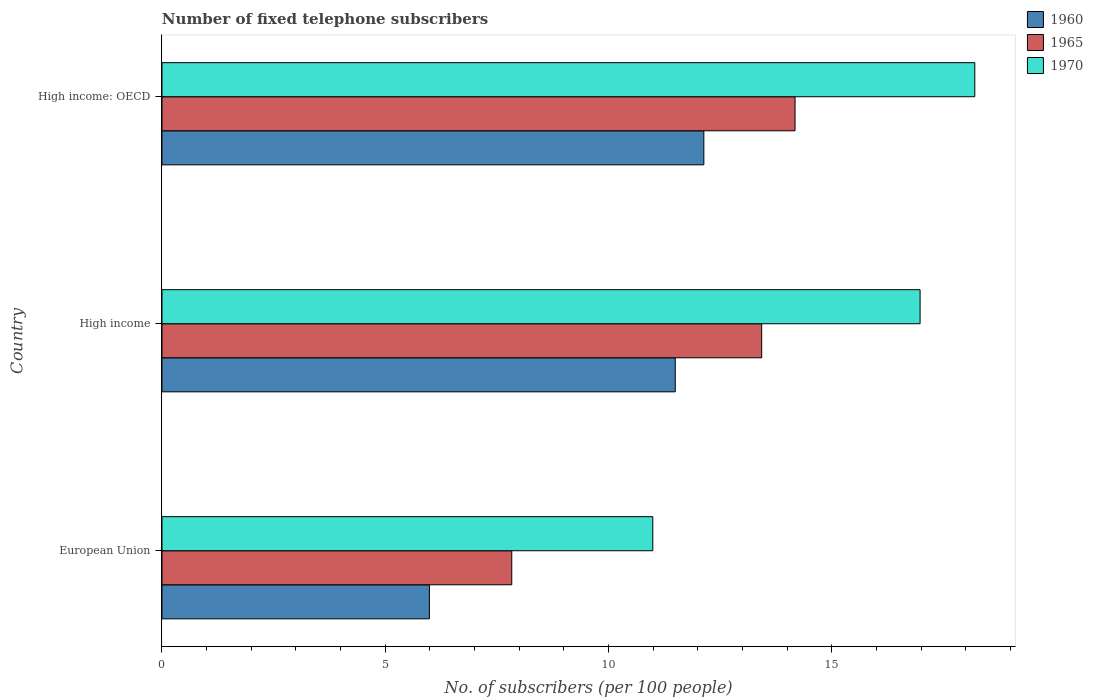How many different coloured bars are there?
Make the answer very short. 3. How many groups of bars are there?
Offer a terse response. 3. Are the number of bars per tick equal to the number of legend labels?
Provide a succinct answer. Yes. Are the number of bars on each tick of the Y-axis equal?
Your answer should be very brief. Yes. How many bars are there on the 3rd tick from the top?
Your response must be concise. 3. In how many cases, is the number of bars for a given country not equal to the number of legend labels?
Your response must be concise. 0. What is the number of fixed telephone subscribers in 1970 in High income?
Offer a terse response. 16.97. Across all countries, what is the maximum number of fixed telephone subscribers in 1960?
Your answer should be compact. 12.13. Across all countries, what is the minimum number of fixed telephone subscribers in 1970?
Offer a very short reply. 10.99. In which country was the number of fixed telephone subscribers in 1970 maximum?
Your answer should be very brief. High income: OECD. What is the total number of fixed telephone subscribers in 1965 in the graph?
Ensure brevity in your answer.  35.43. What is the difference between the number of fixed telephone subscribers in 1965 in European Union and that in High income?
Your response must be concise. -5.6. What is the difference between the number of fixed telephone subscribers in 1960 in High income: OECD and the number of fixed telephone subscribers in 1970 in European Union?
Ensure brevity in your answer.  1.14. What is the average number of fixed telephone subscribers in 1970 per country?
Make the answer very short. 15.39. What is the difference between the number of fixed telephone subscribers in 1965 and number of fixed telephone subscribers in 1970 in European Union?
Your answer should be compact. -3.16. What is the ratio of the number of fixed telephone subscribers in 1960 in European Union to that in High income: OECD?
Ensure brevity in your answer.  0.49. Is the number of fixed telephone subscribers in 1970 in European Union less than that in High income: OECD?
Offer a very short reply. Yes. What is the difference between the highest and the second highest number of fixed telephone subscribers in 1960?
Offer a terse response. 0.64. What is the difference between the highest and the lowest number of fixed telephone subscribers in 1965?
Make the answer very short. 6.34. What does the 2nd bar from the top in High income: OECD represents?
Your answer should be compact. 1965. Is it the case that in every country, the sum of the number of fixed telephone subscribers in 1960 and number of fixed telephone subscribers in 1970 is greater than the number of fixed telephone subscribers in 1965?
Give a very brief answer. Yes. How many bars are there?
Your answer should be very brief. 9. Are all the bars in the graph horizontal?
Your response must be concise. Yes. Are the values on the major ticks of X-axis written in scientific E-notation?
Offer a very short reply. No. Does the graph contain any zero values?
Provide a succinct answer. No. Where does the legend appear in the graph?
Your response must be concise. Top right. What is the title of the graph?
Ensure brevity in your answer.  Number of fixed telephone subscribers. What is the label or title of the X-axis?
Keep it short and to the point. No. of subscribers (per 100 people). What is the No. of subscribers (per 100 people) in 1960 in European Union?
Your answer should be very brief. 5.99. What is the No. of subscribers (per 100 people) of 1965 in European Union?
Offer a terse response. 7.83. What is the No. of subscribers (per 100 people) in 1970 in European Union?
Your answer should be compact. 10.99. What is the No. of subscribers (per 100 people) of 1960 in High income?
Your response must be concise. 11.49. What is the No. of subscribers (per 100 people) in 1965 in High income?
Make the answer very short. 13.43. What is the No. of subscribers (per 100 people) of 1970 in High income?
Your answer should be compact. 16.97. What is the No. of subscribers (per 100 people) of 1960 in High income: OECD?
Provide a succinct answer. 12.13. What is the No. of subscribers (per 100 people) of 1965 in High income: OECD?
Your answer should be very brief. 14.17. What is the No. of subscribers (per 100 people) in 1970 in High income: OECD?
Your answer should be very brief. 18.2. Across all countries, what is the maximum No. of subscribers (per 100 people) of 1960?
Provide a short and direct response. 12.13. Across all countries, what is the maximum No. of subscribers (per 100 people) of 1965?
Offer a very short reply. 14.17. Across all countries, what is the maximum No. of subscribers (per 100 people) in 1970?
Give a very brief answer. 18.2. Across all countries, what is the minimum No. of subscribers (per 100 people) of 1960?
Your answer should be compact. 5.99. Across all countries, what is the minimum No. of subscribers (per 100 people) of 1965?
Provide a short and direct response. 7.83. Across all countries, what is the minimum No. of subscribers (per 100 people) of 1970?
Offer a terse response. 10.99. What is the total No. of subscribers (per 100 people) in 1960 in the graph?
Make the answer very short. 29.61. What is the total No. of subscribers (per 100 people) in 1965 in the graph?
Keep it short and to the point. 35.43. What is the total No. of subscribers (per 100 people) in 1970 in the graph?
Offer a terse response. 46.16. What is the difference between the No. of subscribers (per 100 people) in 1960 in European Union and that in High income?
Provide a short and direct response. -5.5. What is the difference between the No. of subscribers (per 100 people) in 1965 in European Union and that in High income?
Your answer should be compact. -5.6. What is the difference between the No. of subscribers (per 100 people) of 1970 in European Union and that in High income?
Your response must be concise. -5.98. What is the difference between the No. of subscribers (per 100 people) in 1960 in European Union and that in High income: OECD?
Make the answer very short. -6.14. What is the difference between the No. of subscribers (per 100 people) in 1965 in European Union and that in High income: OECD?
Make the answer very short. -6.34. What is the difference between the No. of subscribers (per 100 people) in 1970 in European Union and that in High income: OECD?
Provide a succinct answer. -7.21. What is the difference between the No. of subscribers (per 100 people) in 1960 in High income and that in High income: OECD?
Make the answer very short. -0.64. What is the difference between the No. of subscribers (per 100 people) in 1965 in High income and that in High income: OECD?
Your response must be concise. -0.75. What is the difference between the No. of subscribers (per 100 people) of 1970 in High income and that in High income: OECD?
Your answer should be compact. -1.22. What is the difference between the No. of subscribers (per 100 people) in 1960 in European Union and the No. of subscribers (per 100 people) in 1965 in High income?
Your answer should be compact. -7.44. What is the difference between the No. of subscribers (per 100 people) of 1960 in European Union and the No. of subscribers (per 100 people) of 1970 in High income?
Keep it short and to the point. -10.99. What is the difference between the No. of subscribers (per 100 people) of 1965 in European Union and the No. of subscribers (per 100 people) of 1970 in High income?
Give a very brief answer. -9.14. What is the difference between the No. of subscribers (per 100 people) of 1960 in European Union and the No. of subscribers (per 100 people) of 1965 in High income: OECD?
Make the answer very short. -8.19. What is the difference between the No. of subscribers (per 100 people) of 1960 in European Union and the No. of subscribers (per 100 people) of 1970 in High income: OECD?
Ensure brevity in your answer.  -12.21. What is the difference between the No. of subscribers (per 100 people) in 1965 in European Union and the No. of subscribers (per 100 people) in 1970 in High income: OECD?
Your answer should be compact. -10.37. What is the difference between the No. of subscribers (per 100 people) of 1960 in High income and the No. of subscribers (per 100 people) of 1965 in High income: OECD?
Offer a terse response. -2.68. What is the difference between the No. of subscribers (per 100 people) of 1960 in High income and the No. of subscribers (per 100 people) of 1970 in High income: OECD?
Provide a short and direct response. -6.71. What is the difference between the No. of subscribers (per 100 people) of 1965 in High income and the No. of subscribers (per 100 people) of 1970 in High income: OECD?
Offer a terse response. -4.77. What is the average No. of subscribers (per 100 people) in 1960 per country?
Your response must be concise. 9.87. What is the average No. of subscribers (per 100 people) in 1965 per country?
Your response must be concise. 11.81. What is the average No. of subscribers (per 100 people) of 1970 per country?
Keep it short and to the point. 15.39. What is the difference between the No. of subscribers (per 100 people) in 1960 and No. of subscribers (per 100 people) in 1965 in European Union?
Offer a very short reply. -1.84. What is the difference between the No. of subscribers (per 100 people) in 1960 and No. of subscribers (per 100 people) in 1970 in European Union?
Your answer should be compact. -5. What is the difference between the No. of subscribers (per 100 people) in 1965 and No. of subscribers (per 100 people) in 1970 in European Union?
Your answer should be very brief. -3.16. What is the difference between the No. of subscribers (per 100 people) in 1960 and No. of subscribers (per 100 people) in 1965 in High income?
Provide a short and direct response. -1.93. What is the difference between the No. of subscribers (per 100 people) in 1960 and No. of subscribers (per 100 people) in 1970 in High income?
Your answer should be compact. -5.48. What is the difference between the No. of subscribers (per 100 people) of 1965 and No. of subscribers (per 100 people) of 1970 in High income?
Provide a short and direct response. -3.55. What is the difference between the No. of subscribers (per 100 people) in 1960 and No. of subscribers (per 100 people) in 1965 in High income: OECD?
Ensure brevity in your answer.  -2.04. What is the difference between the No. of subscribers (per 100 people) of 1960 and No. of subscribers (per 100 people) of 1970 in High income: OECD?
Give a very brief answer. -6.07. What is the difference between the No. of subscribers (per 100 people) in 1965 and No. of subscribers (per 100 people) in 1970 in High income: OECD?
Keep it short and to the point. -4.02. What is the ratio of the No. of subscribers (per 100 people) in 1960 in European Union to that in High income?
Keep it short and to the point. 0.52. What is the ratio of the No. of subscribers (per 100 people) of 1965 in European Union to that in High income?
Ensure brevity in your answer.  0.58. What is the ratio of the No. of subscribers (per 100 people) of 1970 in European Union to that in High income?
Keep it short and to the point. 0.65. What is the ratio of the No. of subscribers (per 100 people) of 1960 in European Union to that in High income: OECD?
Your answer should be compact. 0.49. What is the ratio of the No. of subscribers (per 100 people) of 1965 in European Union to that in High income: OECD?
Your response must be concise. 0.55. What is the ratio of the No. of subscribers (per 100 people) of 1970 in European Union to that in High income: OECD?
Make the answer very short. 0.6. What is the ratio of the No. of subscribers (per 100 people) in 1960 in High income to that in High income: OECD?
Your answer should be very brief. 0.95. What is the ratio of the No. of subscribers (per 100 people) of 1965 in High income to that in High income: OECD?
Your answer should be compact. 0.95. What is the ratio of the No. of subscribers (per 100 people) in 1970 in High income to that in High income: OECD?
Provide a succinct answer. 0.93. What is the difference between the highest and the second highest No. of subscribers (per 100 people) in 1960?
Make the answer very short. 0.64. What is the difference between the highest and the second highest No. of subscribers (per 100 people) of 1965?
Offer a terse response. 0.75. What is the difference between the highest and the second highest No. of subscribers (per 100 people) in 1970?
Make the answer very short. 1.22. What is the difference between the highest and the lowest No. of subscribers (per 100 people) in 1960?
Keep it short and to the point. 6.14. What is the difference between the highest and the lowest No. of subscribers (per 100 people) in 1965?
Provide a succinct answer. 6.34. What is the difference between the highest and the lowest No. of subscribers (per 100 people) of 1970?
Give a very brief answer. 7.21. 